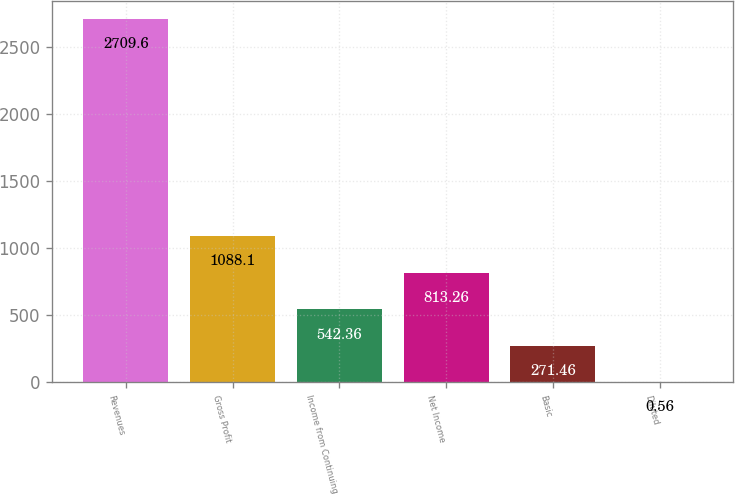Convert chart. <chart><loc_0><loc_0><loc_500><loc_500><bar_chart><fcel>Revenues<fcel>Gross Profit<fcel>Income from Continuing<fcel>Net Income<fcel>Basic<fcel>Diluted<nl><fcel>2709.6<fcel>1088.1<fcel>542.36<fcel>813.26<fcel>271.46<fcel>0.56<nl></chart> 